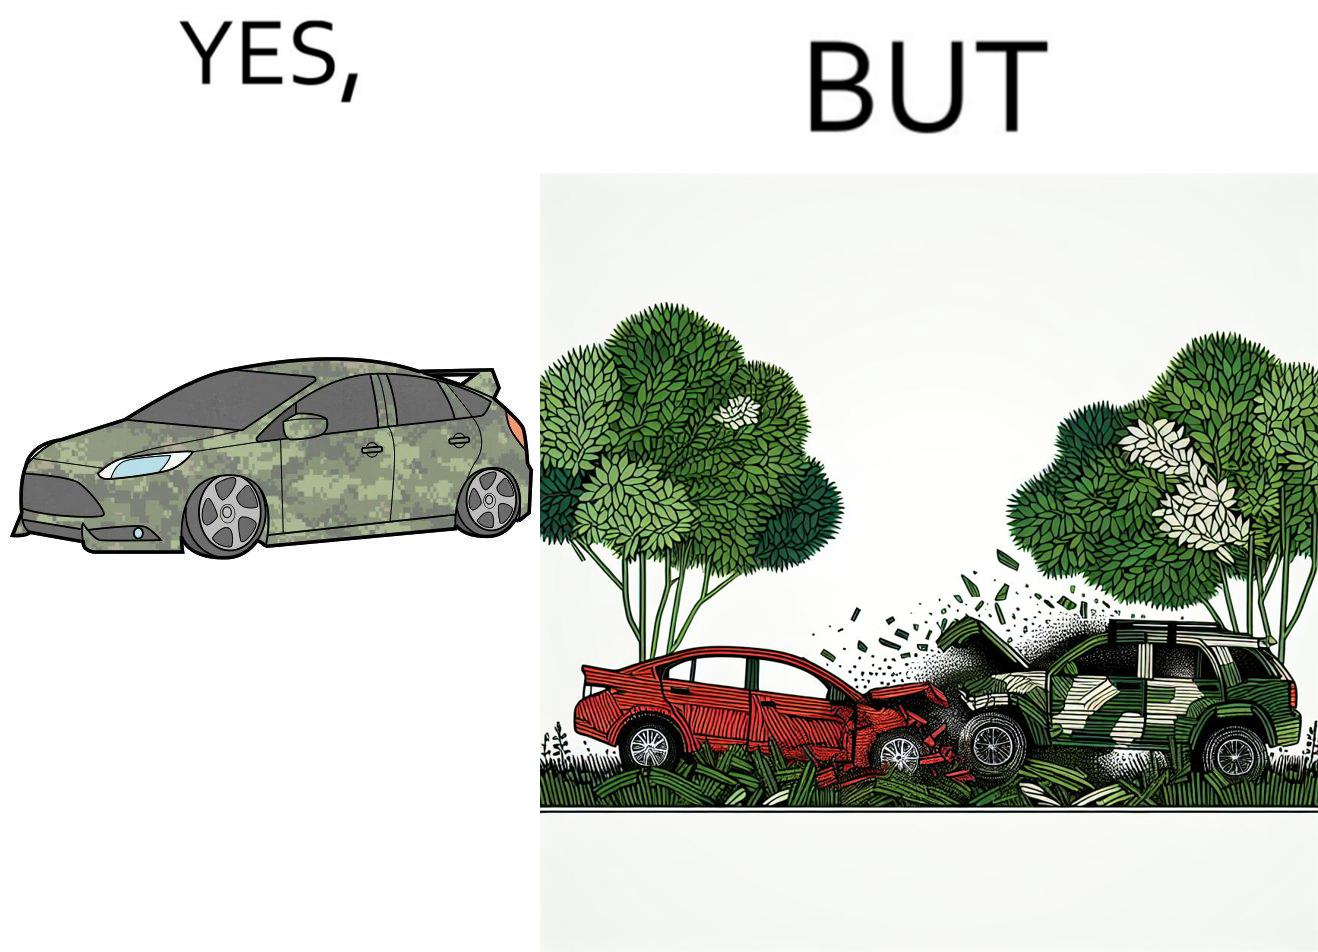What is the satirical meaning behind this image? The image is ironic, because in the left image a car is painted in camouflage color but in the right image the same car is getting involved in accident to due to its color as other drivers face difficulty in recognizing the colors 